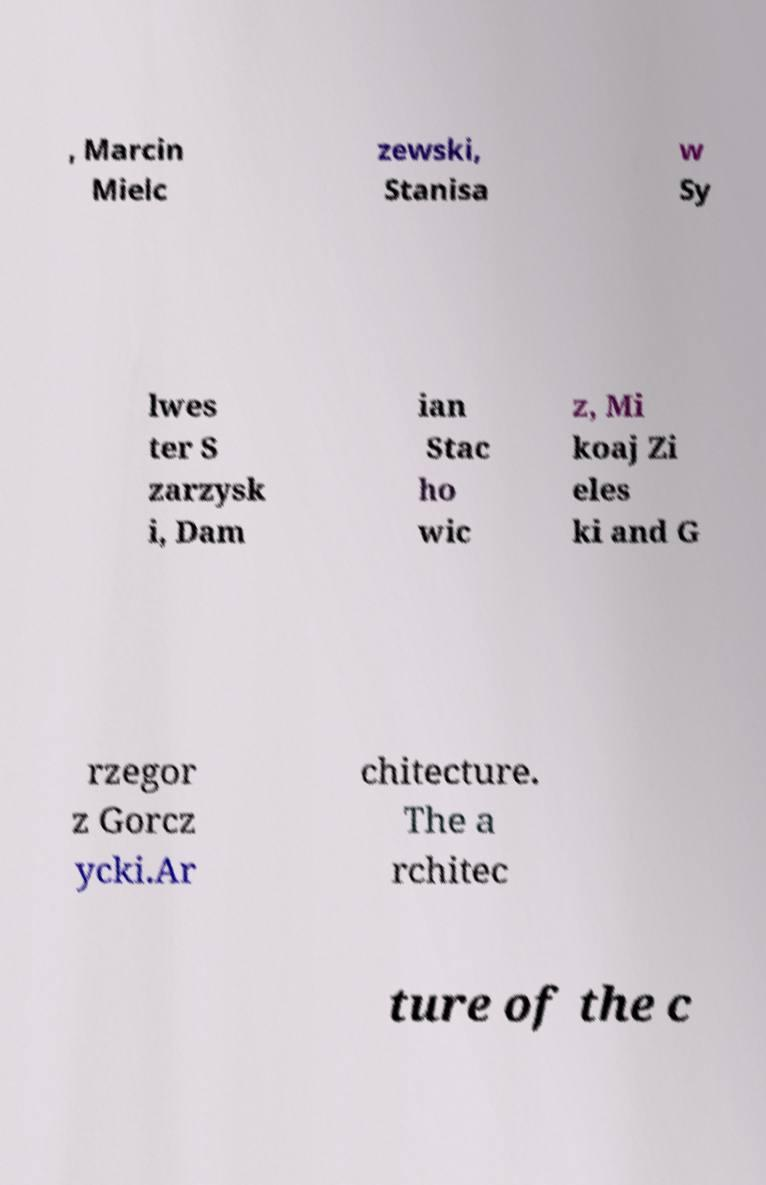Please read and relay the text visible in this image. What does it say? , Marcin Mielc zewski, Stanisa w Sy lwes ter S zarzysk i, Dam ian Stac ho wic z, Mi koaj Zi eles ki and G rzegor z Gorcz ycki.Ar chitecture. The a rchitec ture of the c 